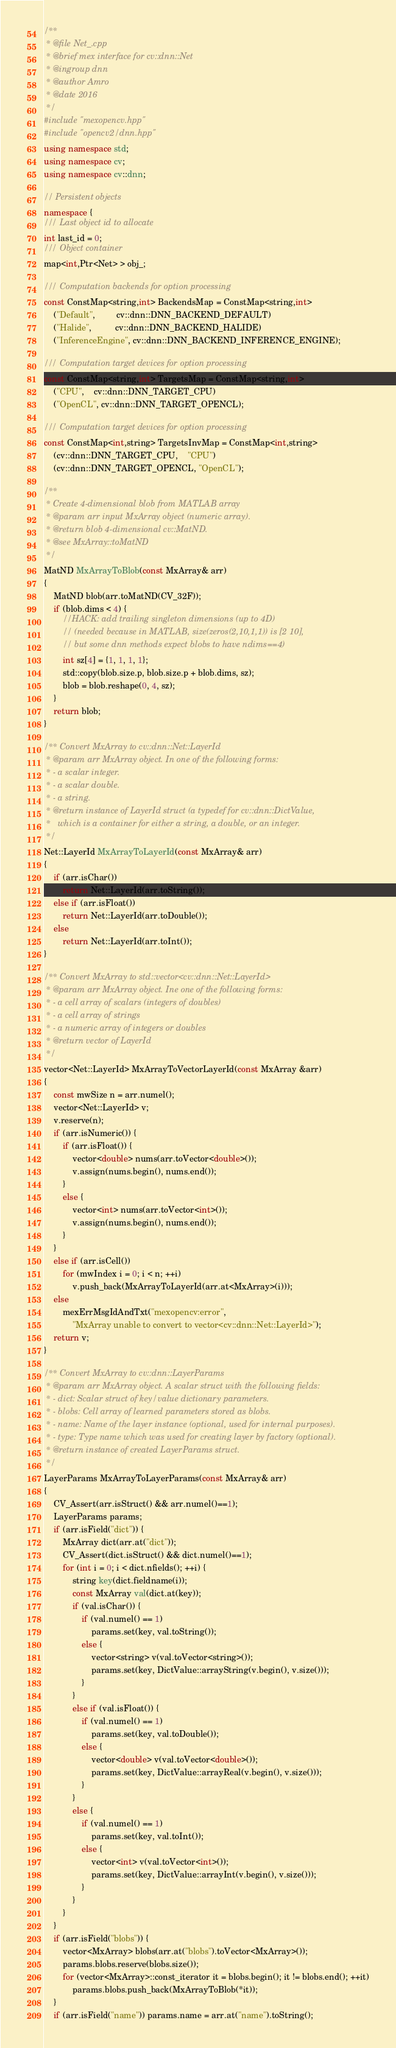<code> <loc_0><loc_0><loc_500><loc_500><_C++_>/**
 * @file Net_.cpp
 * @brief mex interface for cv::dnn::Net
 * @ingroup dnn
 * @author Amro
 * @date 2016
 */
#include "mexopencv.hpp"
#include "opencv2/dnn.hpp"
using namespace std;
using namespace cv;
using namespace cv::dnn;

// Persistent objects
namespace {
/// Last object id to allocate
int last_id = 0;
/// Object container
map<int,Ptr<Net> > obj_;

/// Computation backends for option processing
const ConstMap<string,int> BackendsMap = ConstMap<string,int>
    ("Default",         cv::dnn::DNN_BACKEND_DEFAULT)
    ("Halide",          cv::dnn::DNN_BACKEND_HALIDE)
    ("InferenceEngine", cv::dnn::DNN_BACKEND_INFERENCE_ENGINE);

/// Computation target devices for option processing
const ConstMap<string,int> TargetsMap = ConstMap<string,int>
    ("CPU",    cv::dnn::DNN_TARGET_CPU)
    ("OpenCL", cv::dnn::DNN_TARGET_OPENCL);

/// Computation target devices for option processing
const ConstMap<int,string> TargetsInvMap = ConstMap<int,string>
    (cv::dnn::DNN_TARGET_CPU,    "CPU")
    (cv::dnn::DNN_TARGET_OPENCL, "OpenCL");

/**
 * Create 4-dimensional blob from MATLAB array
 * @param arr input MxArray object (numeric array).
 * @return blob 4-dimensional cv::MatND.
 * @see MxArray::toMatND
 */
MatND MxArrayToBlob(const MxArray& arr)
{
    MatND blob(arr.toMatND(CV_32F));
    if (blob.dims < 4) {
        //HACK: add trailing singleton dimensions (up to 4D)
        // (needed because in MATLAB, size(zeros(2,10,1,1)) is [2 10],
        // but some dnn methods expect blobs to have ndims==4)
        int sz[4] = {1, 1, 1, 1};
        std::copy(blob.size.p, blob.size.p + blob.dims, sz);
        blob = blob.reshape(0, 4, sz);
    }
    return blob;
}

/** Convert MxArray to cv::dnn::Net::LayerId
 * @param arr MxArray object. In one of the following forms:
 * - a scalar integer.
 * - a scalar double.
 * - a string.
 * @return instance of LayerId struct (a typedef for cv::dnn::DictValue,
 *   which is a container for either a string, a double, or an integer.
 */
Net::LayerId MxArrayToLayerId(const MxArray& arr)
{
    if (arr.isChar())
        return Net::LayerId(arr.toString());
    else if (arr.isFloat())
        return Net::LayerId(arr.toDouble());
    else
        return Net::LayerId(arr.toInt());
}

/** Convert MxArray to std::vector<cv::dnn::Net::LayerId>
 * @param arr MxArray object. Ine one of the following forms:
 * - a cell array of scalars (integers of doubles)
 * - a cell array of strings
 * - a numeric array of integers or doubles
 * @return vector of LayerId
 */
vector<Net::LayerId> MxArrayToVectorLayerId(const MxArray &arr)
{
    const mwSize n = arr.numel();
    vector<Net::LayerId> v;
    v.reserve(n);
    if (arr.isNumeric()) {
        if (arr.isFloat()) {
            vector<double> nums(arr.toVector<double>());
            v.assign(nums.begin(), nums.end());
        }
        else {
            vector<int> nums(arr.toVector<int>());
            v.assign(nums.begin(), nums.end());
        }
    }
    else if (arr.isCell())
        for (mwIndex i = 0; i < n; ++i)
            v.push_back(MxArrayToLayerId(arr.at<MxArray>(i)));
    else
        mexErrMsgIdAndTxt("mexopencv:error",
            "MxArray unable to convert to vector<cv::dnn::Net::LayerId>");
    return v;
}

/** Convert MxArray to cv::dnn::LayerParams
 * @param arr MxArray object. A scalar struct with the following fields:
 * - dict: Scalar struct of key/value dictionary parameters.
 * - blobs: Cell array of learned parameters stored as blobs.
 * - name: Name of the layer instance (optional, used for internal purposes).
 * - type: Type name which was used for creating layer by factory (optional).
 * @return instance of created LayerParams struct.
 */
LayerParams MxArrayToLayerParams(const MxArray& arr)
{
    CV_Assert(arr.isStruct() && arr.numel()==1);
    LayerParams params;
    if (arr.isField("dict")) {
        MxArray dict(arr.at("dict"));
        CV_Assert(dict.isStruct() && dict.numel()==1);
        for (int i = 0; i < dict.nfields(); ++i) {
            string key(dict.fieldname(i));
            const MxArray val(dict.at(key));
            if (val.isChar()) {
                if (val.numel() == 1)
                    params.set(key, val.toString());
                else {
                    vector<string> v(val.toVector<string>());
                    params.set(key, DictValue::arrayString(v.begin(), v.size()));
                }
            }
            else if (val.isFloat()) {
                if (val.numel() == 1)
                    params.set(key, val.toDouble());
                else {
                    vector<double> v(val.toVector<double>());
                    params.set(key, DictValue::arrayReal(v.begin(), v.size()));
                }
            }
            else {
                if (val.numel() == 1)
                    params.set(key, val.toInt());
                else {
                    vector<int> v(val.toVector<int>());
                    params.set(key, DictValue::arrayInt(v.begin(), v.size()));
                }
            }
        }
    }
    if (arr.isField("blobs")) {
        vector<MxArray> blobs(arr.at("blobs").toVector<MxArray>());
        params.blobs.reserve(blobs.size());
        for (vector<MxArray>::const_iterator it = blobs.begin(); it != blobs.end(); ++it)
            params.blobs.push_back(MxArrayToBlob(*it));
    }
    if (arr.isField("name")) params.name = arr.at("name").toString();</code> 